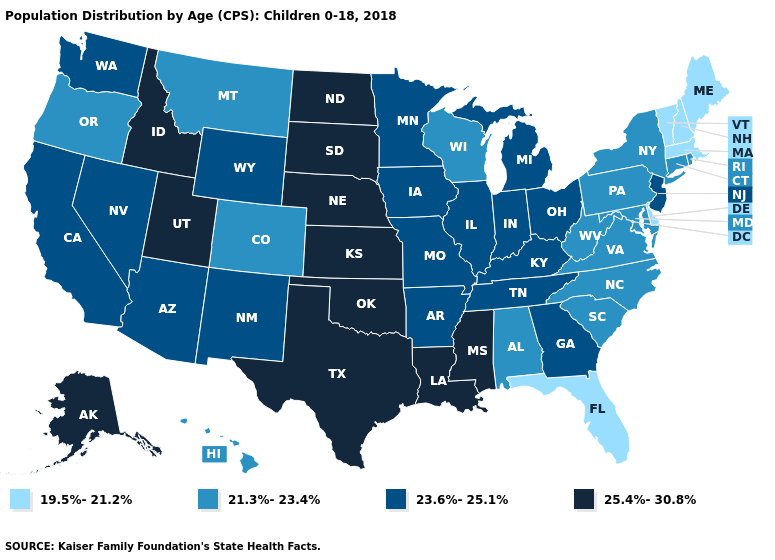What is the value of Massachusetts?
Concise answer only. 19.5%-21.2%. Does the first symbol in the legend represent the smallest category?
Answer briefly. Yes. Does California have the lowest value in the USA?
Short answer required. No. Name the states that have a value in the range 21.3%-23.4%?
Write a very short answer. Alabama, Colorado, Connecticut, Hawaii, Maryland, Montana, New York, North Carolina, Oregon, Pennsylvania, Rhode Island, South Carolina, Virginia, West Virginia, Wisconsin. How many symbols are there in the legend?
Short answer required. 4. What is the value of Wyoming?
Answer briefly. 23.6%-25.1%. Which states have the highest value in the USA?
Short answer required. Alaska, Idaho, Kansas, Louisiana, Mississippi, Nebraska, North Dakota, Oklahoma, South Dakota, Texas, Utah. Which states have the highest value in the USA?
Short answer required. Alaska, Idaho, Kansas, Louisiana, Mississippi, Nebraska, North Dakota, Oklahoma, South Dakota, Texas, Utah. Among the states that border Wisconsin , which have the highest value?
Short answer required. Illinois, Iowa, Michigan, Minnesota. Does Iowa have the highest value in the USA?
Concise answer only. No. Does New Hampshire have the lowest value in the Northeast?
Write a very short answer. Yes. Does the map have missing data?
Short answer required. No. Name the states that have a value in the range 25.4%-30.8%?
Short answer required. Alaska, Idaho, Kansas, Louisiana, Mississippi, Nebraska, North Dakota, Oklahoma, South Dakota, Texas, Utah. Which states have the lowest value in the USA?
Give a very brief answer. Delaware, Florida, Maine, Massachusetts, New Hampshire, Vermont. Does Wisconsin have a lower value than Oregon?
Short answer required. No. 